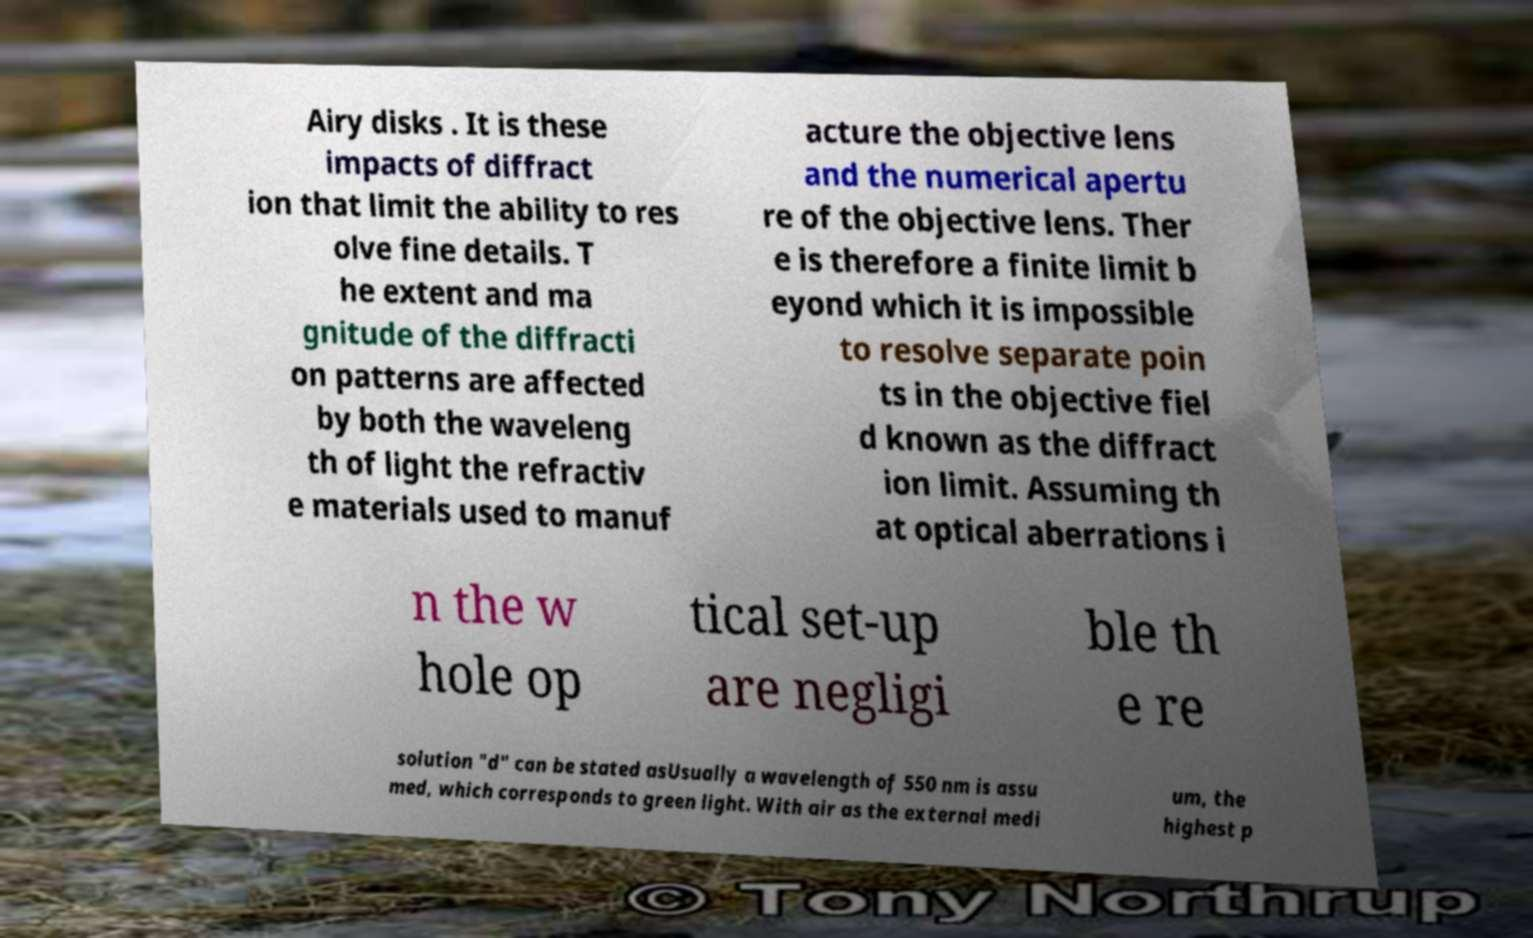Could you extract and type out the text from this image? Airy disks . It is these impacts of diffract ion that limit the ability to res olve fine details. T he extent and ma gnitude of the diffracti on patterns are affected by both the waveleng th of light the refractiv e materials used to manuf acture the objective lens and the numerical apertu re of the objective lens. Ther e is therefore a finite limit b eyond which it is impossible to resolve separate poin ts in the objective fiel d known as the diffract ion limit. Assuming th at optical aberrations i n the w hole op tical set-up are negligi ble th e re solution "d" can be stated asUsually a wavelength of 550 nm is assu med, which corresponds to green light. With air as the external medi um, the highest p 